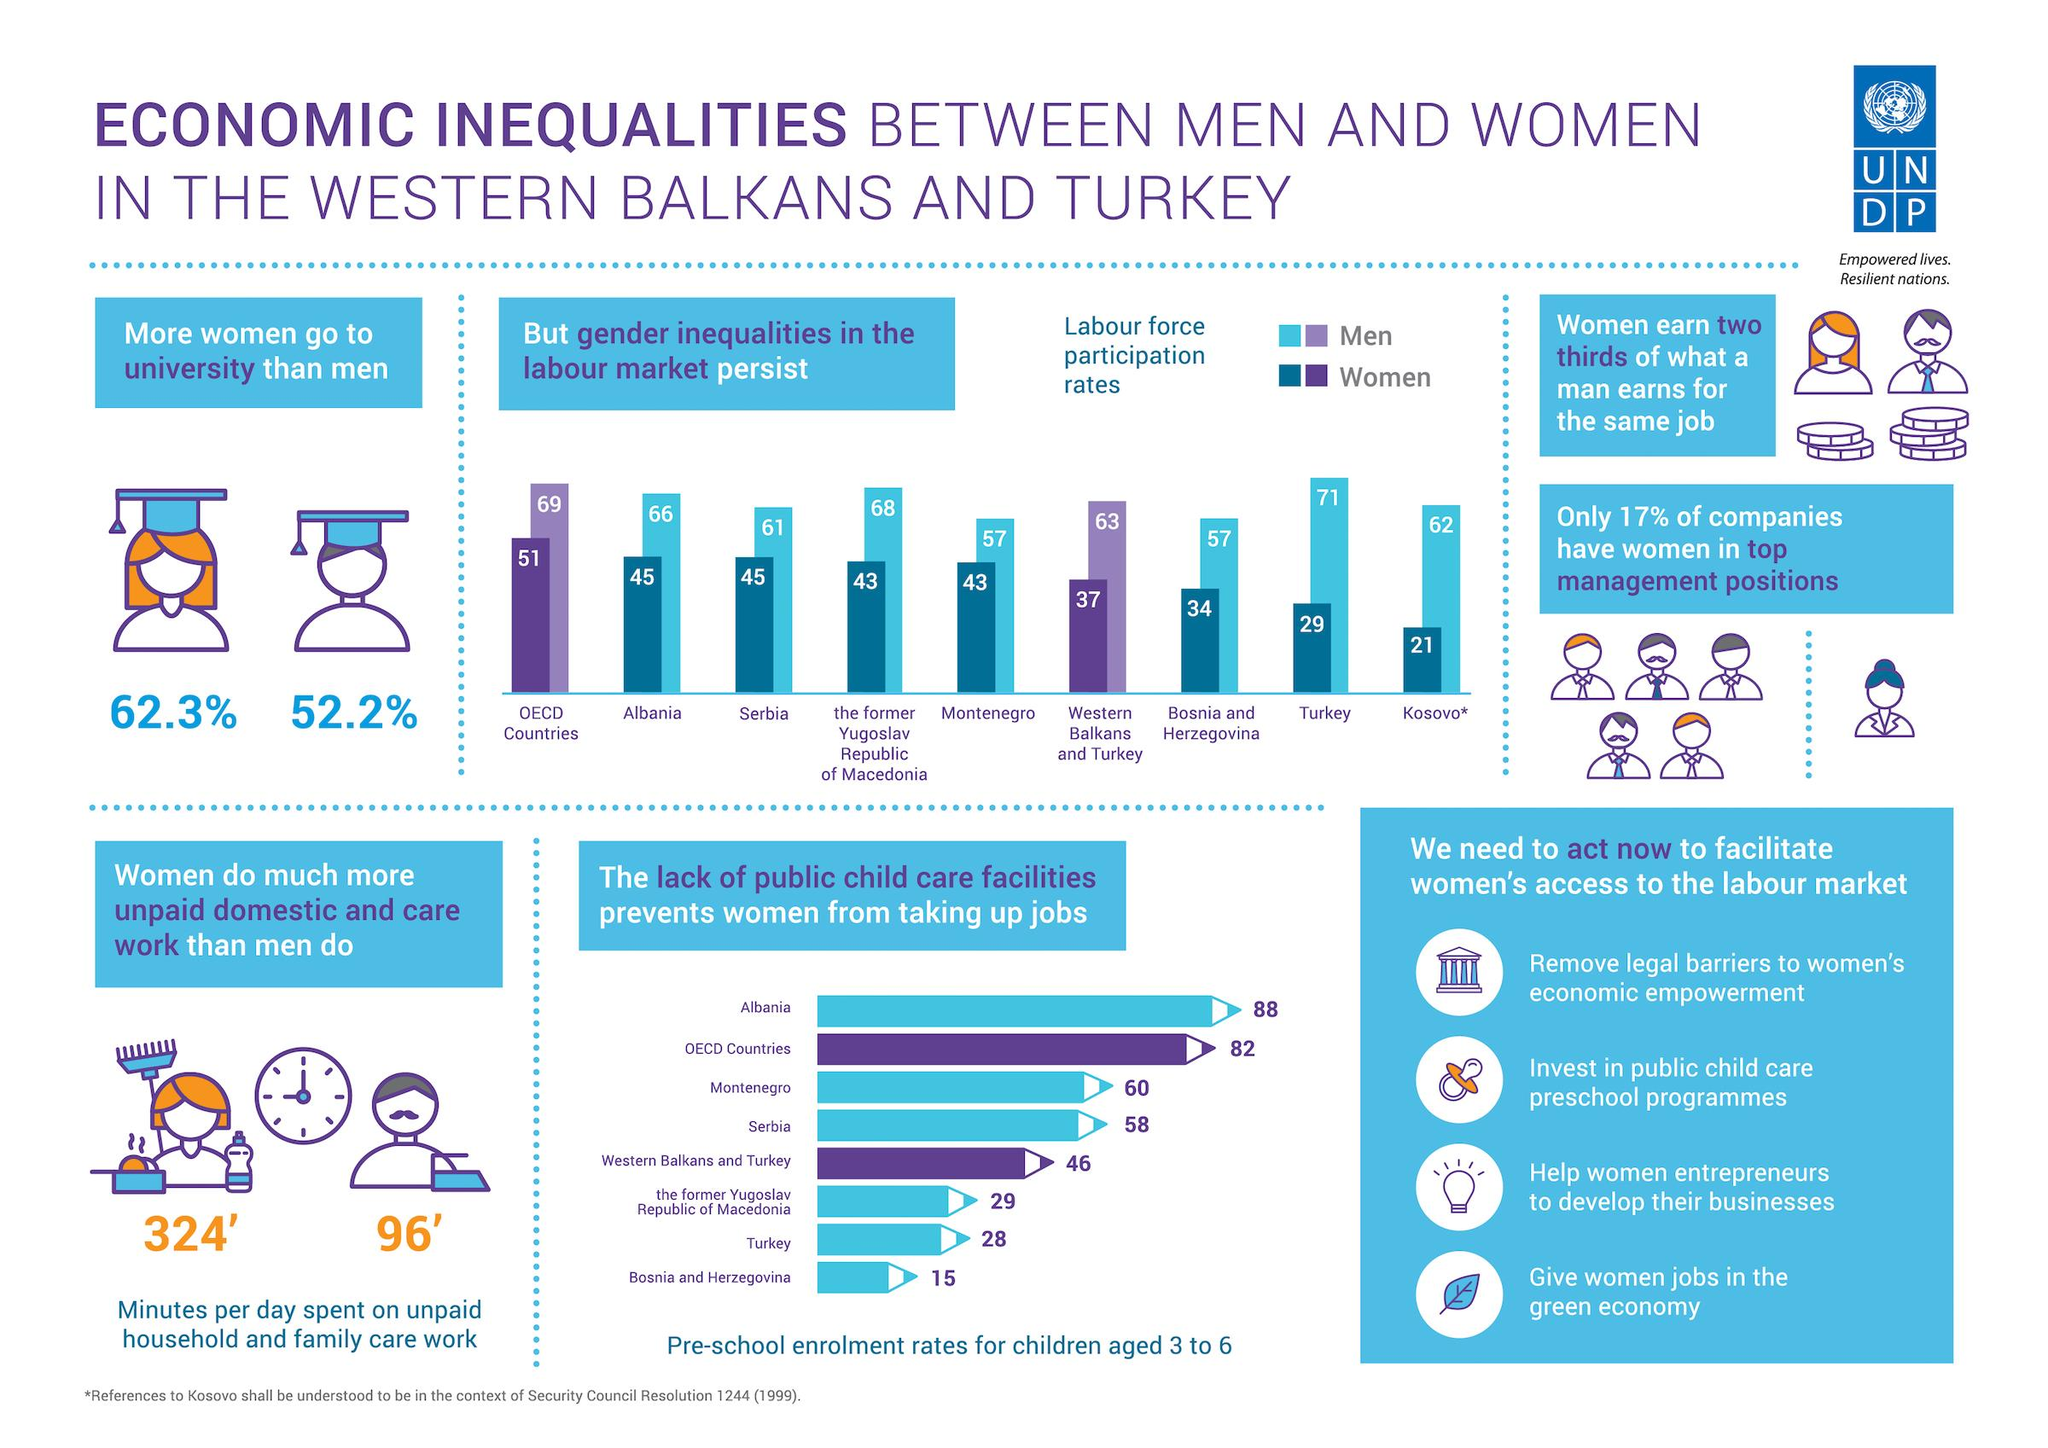Draw attention to some important aspects in this diagram. According to data on pre-school enrollment rates for children aged 3 to 6 in Turkey and Albania, taken together, 116% of children in these two countries are enrolled in pre-school. According to a survey, approximately 47.8% of men do not attend university. According to a survey, 37.7% of women do not attend university. According to a recent study, 83% of companies do not have women in top managed positions. The pre-school enrollment rate for children aged 3 to 6 in Serbia and Montenegro, taken together, is 118%. 